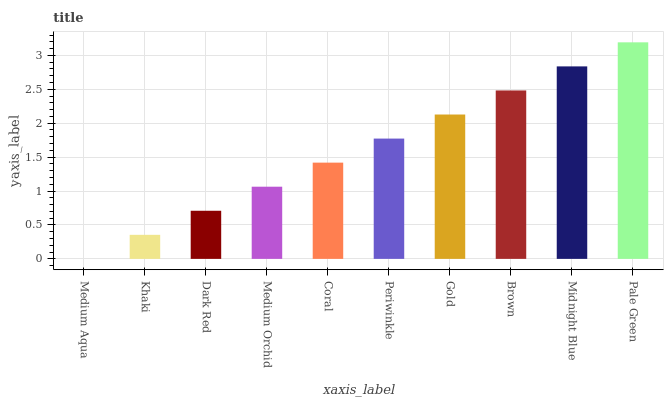Is Medium Aqua the minimum?
Answer yes or no. Yes. Is Pale Green the maximum?
Answer yes or no. Yes. Is Khaki the minimum?
Answer yes or no. No. Is Khaki the maximum?
Answer yes or no. No. Is Khaki greater than Medium Aqua?
Answer yes or no. Yes. Is Medium Aqua less than Khaki?
Answer yes or no. Yes. Is Medium Aqua greater than Khaki?
Answer yes or no. No. Is Khaki less than Medium Aqua?
Answer yes or no. No. Is Periwinkle the high median?
Answer yes or no. Yes. Is Coral the low median?
Answer yes or no. Yes. Is Medium Orchid the high median?
Answer yes or no. No. Is Khaki the low median?
Answer yes or no. No. 